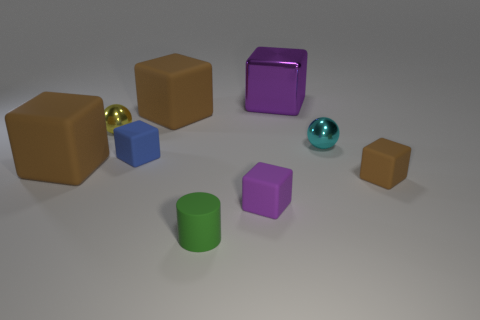Subtract all purple matte cubes. How many cubes are left? 5 Subtract all green cylinders. How many purple cubes are left? 2 Subtract 3 cubes. How many cubes are left? 3 Subtract all brown blocks. How many blocks are left? 3 Subtract all blue blocks. Subtract all gray cylinders. How many blocks are left? 5 Subtract all cylinders. How many objects are left? 8 Subtract 0 green cubes. How many objects are left? 9 Subtract all large purple metal cubes. Subtract all tiny yellow balls. How many objects are left? 7 Add 1 yellow objects. How many yellow objects are left? 2 Add 5 small gray metal objects. How many small gray metal objects exist? 5 